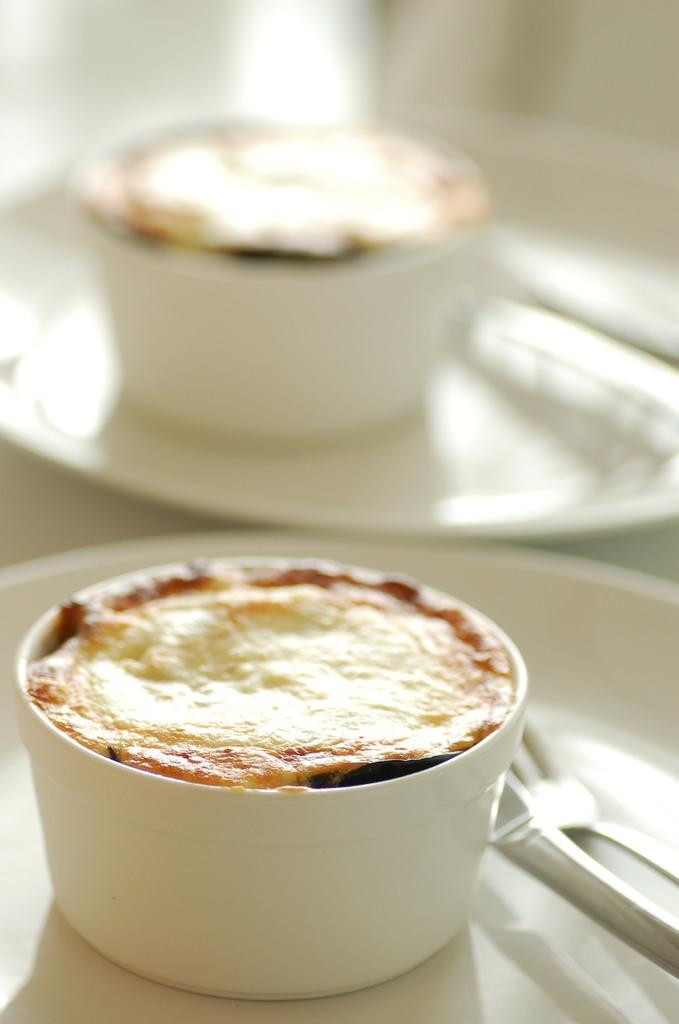What type of food is on the plate in the image? There are two cupcakes on a plate in the image. What utensils are present in the image? There is a knife and a fork in the image. How does the growth of the pigs affect the wave in the image? There are no pigs or waves present in the image, so this question cannot be answered. 